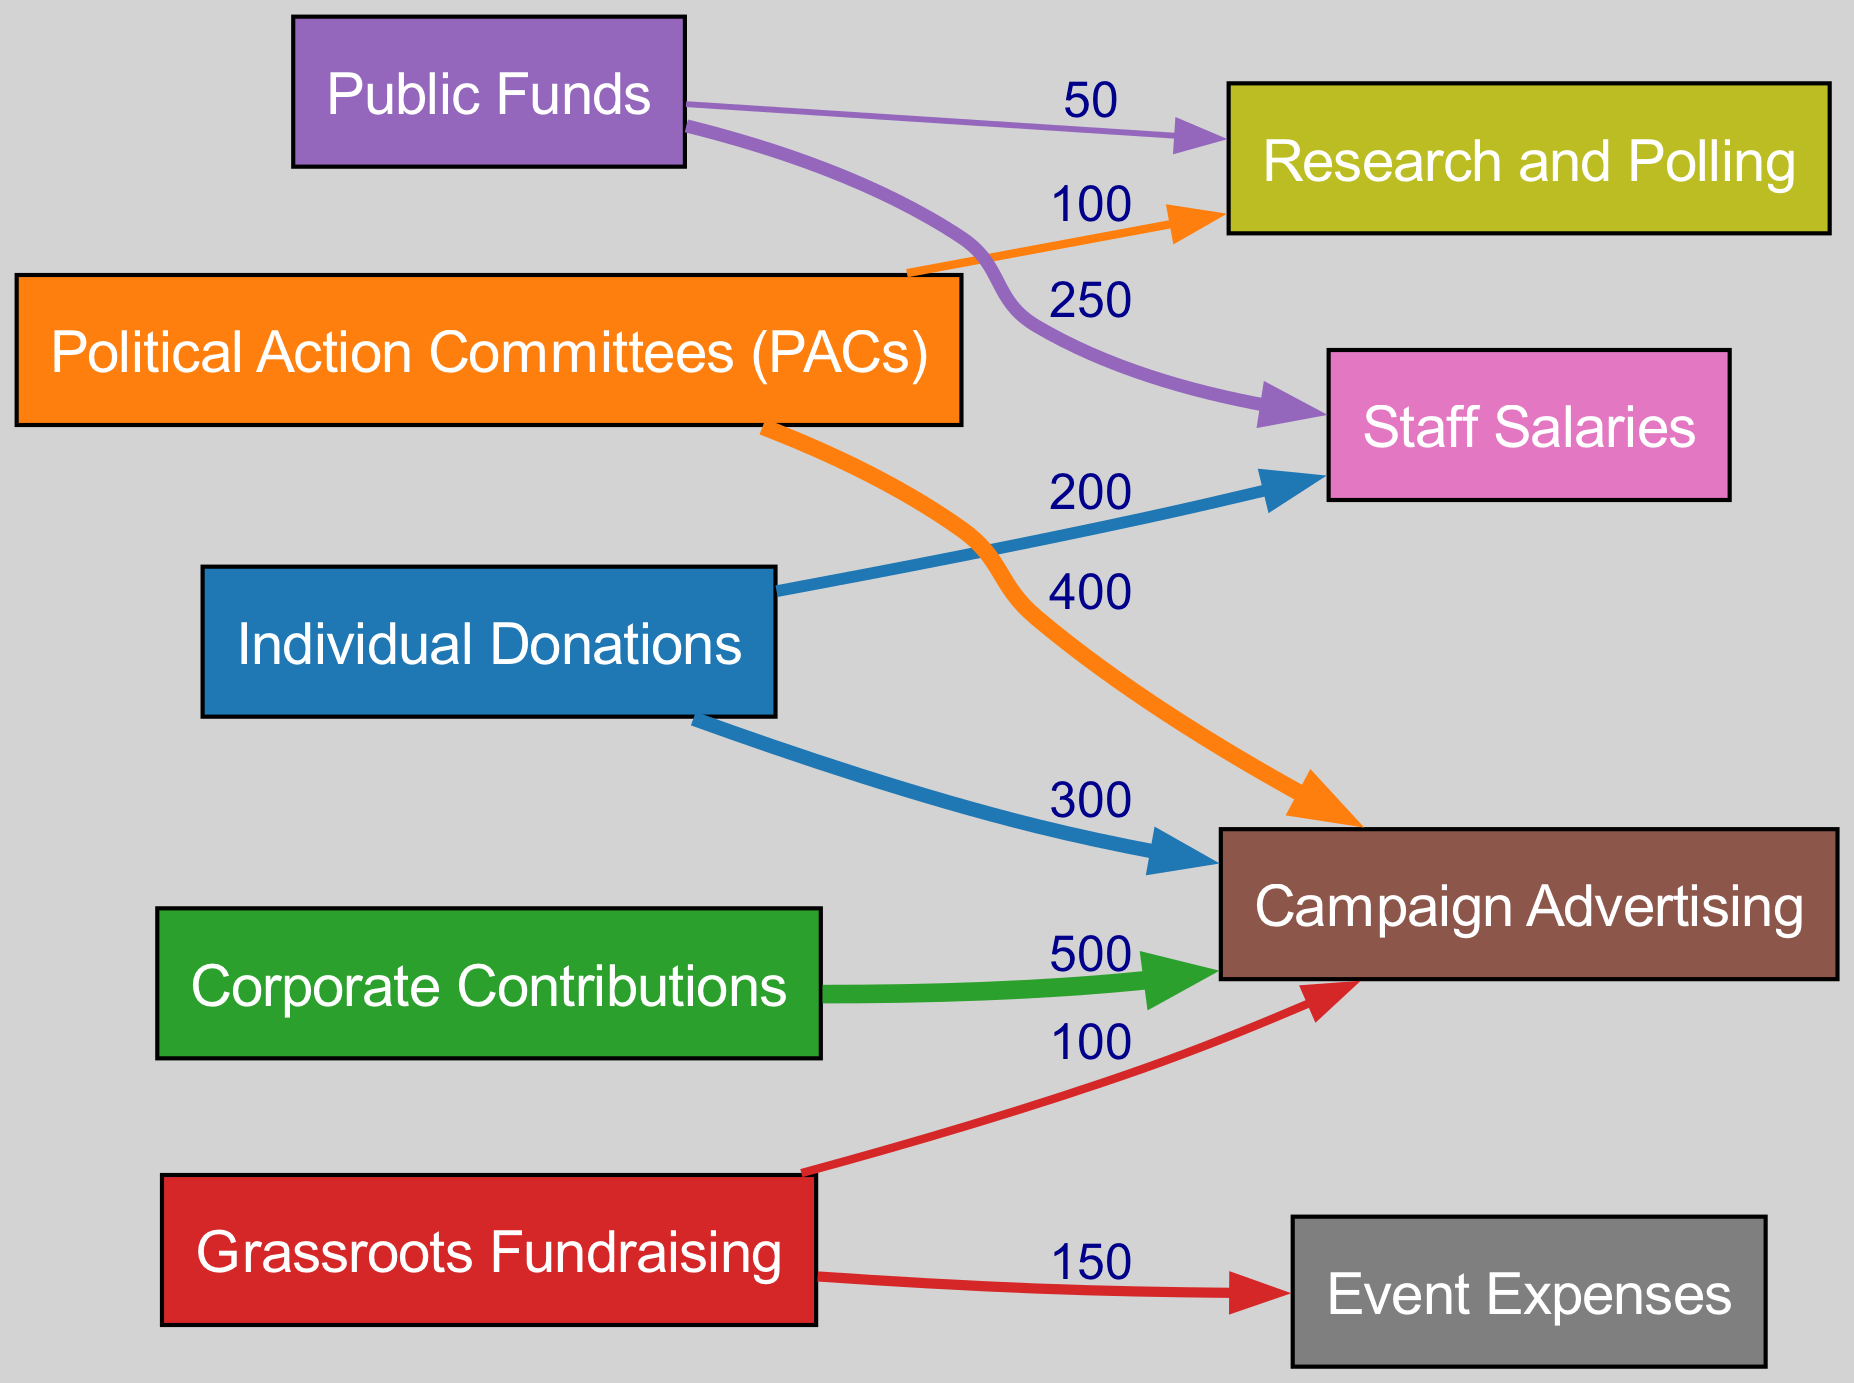What is the total value of contributions from Corporate Contributions to Campaign Advertising? The diagram indicates that Corporate Contributions contribute a value of 500 to Campaign Advertising. This value is stated directly on the linking edge between these two nodes.
Answer: 500 What is the relationship between Political Action Committees and Research and Polling? The diagram shows a direct link from Political Action Committees (PACs) to Research and Polling with a value of 100. This indicates that PACs invest in research and polling for their campaigns.
Answer: 100 How many different sources of campaign funding are represented in the diagram? By counting each unique funding source node in the diagram, we find five distinct sources: Individual Donations, Political Action Committees (PACs), Corporate Contributions, Grassroots Fundraising, and Public Funds.
Answer: 5 What is the total value from Grassroots Fundraising to Event Expenses? The diagram specifies a direct link from Grassroots Fundraising to Event Expenses with a value of 150. This indicates that the total financial contribution from Grassroots Fundraising towards Event Expenses is clearly stated on the linking edge.
Answer: 150 Which funding source contributes the most to Campaign Advertising? Analyzing the diagram, Corporate Contributions contribute the most to Campaign Advertising, with a value of 500, which is higher than the contributions from Individual Donations and Political Action Committees.
Answer: Corporate Contributions How much do Public Funds allocate to Staff Salaries? The diagram directly indicates that Public Funds allocate 250 to Staff Salaries. This amount is shown on the link connecting these two nodes, providing clear information on the funding flow.
Answer: 250 What is the total contribution of Individual Donations to both Campaign Advertising and Staff Salaries? The values connecting Individual Donations to the two targets are 300 for Campaign Advertising and 200 for Staff Salaries. By adding these two amounts together (300 + 200), we find the total contribution from Individual Donations is 500.
Answer: 500 Which expenditure category receives funding from both Individual Donations and Public Funds? The examination of the diagram reveals that Staff Salaries receive funding from both Individual Donations (200) and Public Funds (250), indicating shared financial support for this expenditure.
Answer: Staff Salaries What is the minimum value contributed by a funding source in the diagram? The diagram shows the least contribution from Public Funds to Research and Polling, valued at 50. This is the lowest monetary flow indicated in the links of the diagram.
Answer: 50 